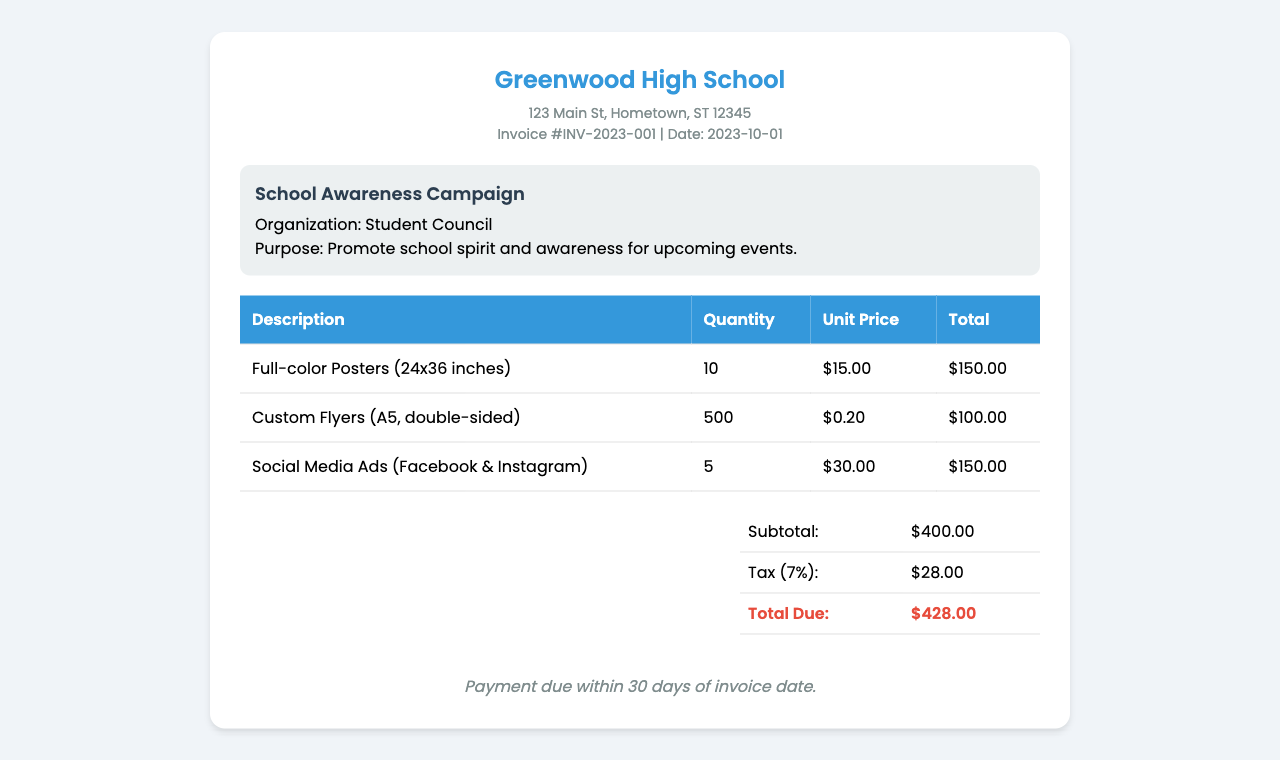What is the name of the school? The name of the school is stated at the top of the document.
Answer: Greenwood High School What is the invoice date? The date of the invoice is mentioned in the invoice details section.
Answer: 2023-10-01 How many full-color posters were ordered? The quantity of full-color posters is listed in the table under quantity.
Answer: 10 What is the total amount due for the invoice? The total amount due is specified in the summary section of the invoice.
Answer: $428.00 What is the tax rate applied to the subtotal? The tax rate is mentioned in the summary section right above the total due.
Answer: 7% What is the purpose of the campaign? The purpose is stated in the campaign details section of the document.
Answer: Promote school spirit and awareness for upcoming events What is the payment term for the invoice? The payment terms are noted at the bottom of the invoice.
Answer: Payment due within 30 days of invoice date How many social media ads were purchased? The number of social media ads is mentioned in the table under quantity.
Answer: 5 What is the subtotal amount before tax? The subtotal amount is presented in the summary section above the tax calculation.
Answer: $400.00 What type of flyers were ordered? The type of flyers is indicated in the description column of the invoice.
Answer: Custom Flyers (A5, double-sided) 